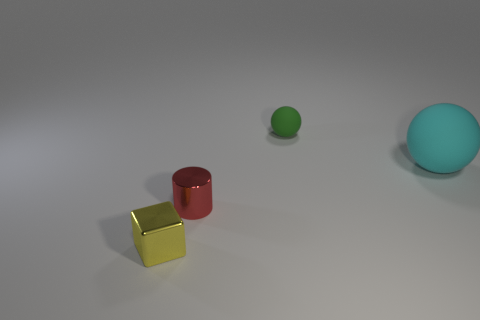There is a sphere behind the rubber ball to the right of the tiny green rubber sphere; what is it made of? The sphere in question appears to be made of a material with a matte finish and a consistent coloration that suggests a synthetic or plastic composition rather than rubber. 